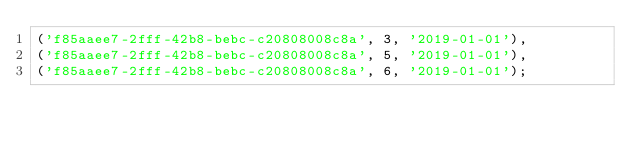Convert code to text. <code><loc_0><loc_0><loc_500><loc_500><_SQL_>('f85aaee7-2fff-42b8-bebc-c20808008c8a', 3, '2019-01-01'),
('f85aaee7-2fff-42b8-bebc-c20808008c8a', 5, '2019-01-01'),
('f85aaee7-2fff-42b8-bebc-c20808008c8a', 6, '2019-01-01');</code> 